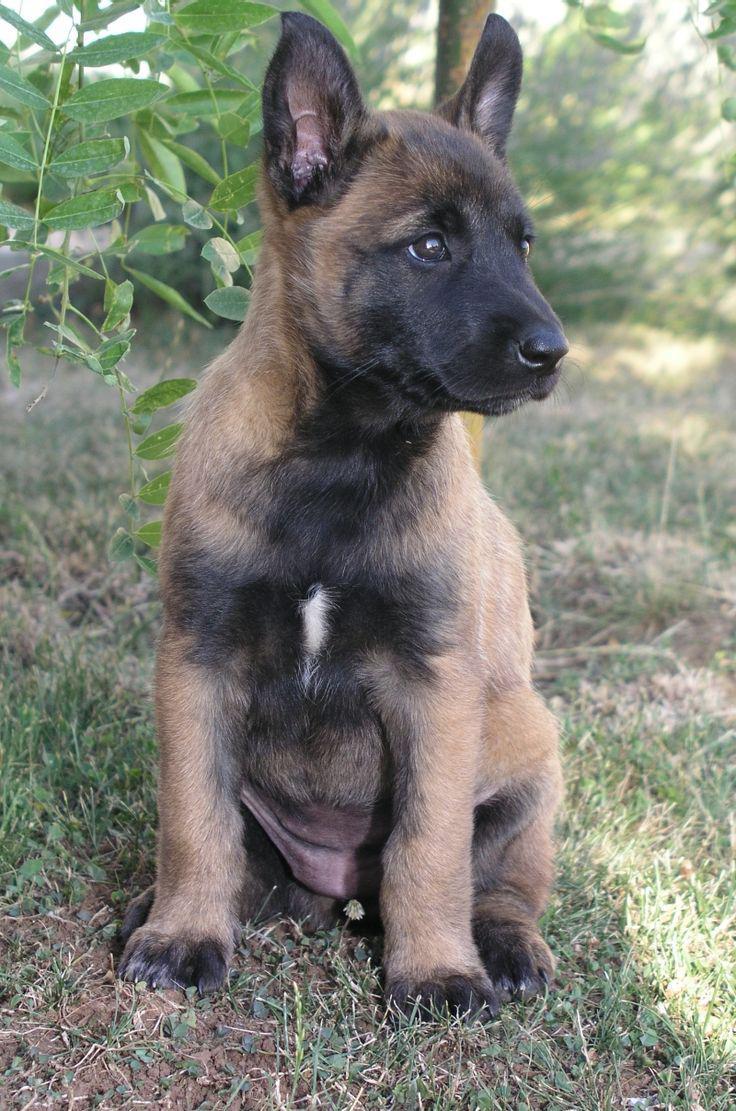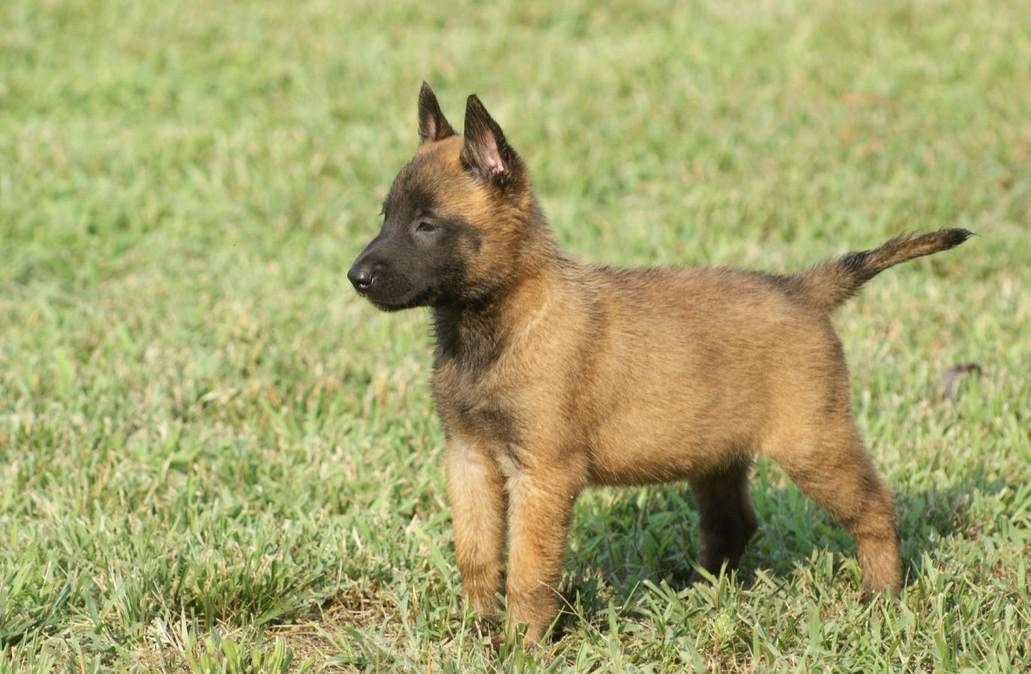The first image is the image on the left, the second image is the image on the right. For the images shown, is this caption "One of the dogs is on a leash." true? Answer yes or no. No. 